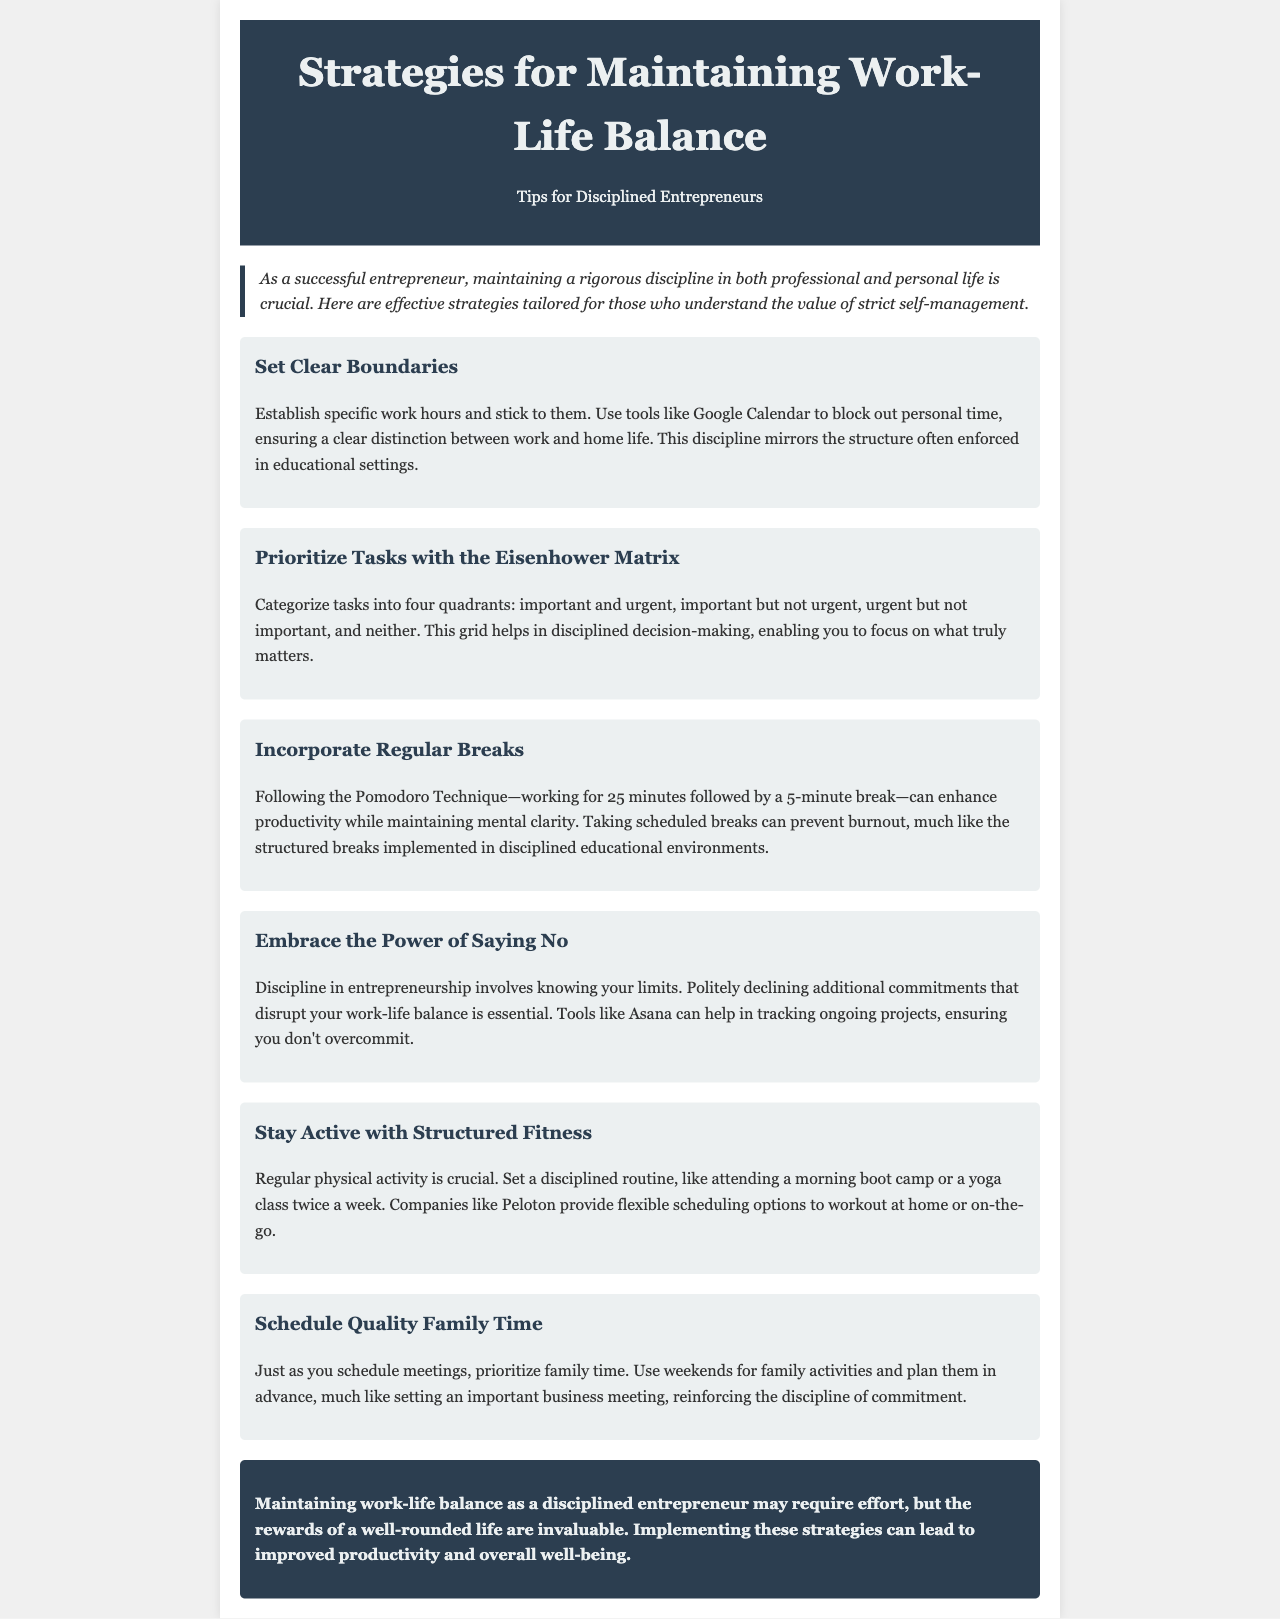What is the title of the newsletter? The title can be found in the header section of the document, prominently displayed.
Answer: Strategies for Maintaining Work-Life Balance What is the first strategy mentioned? The first strategy is presented in a dedicated section with a heading for clarity.
Answer: Set Clear Boundaries How many quadrants are in the Eisenhower Matrix? The Eisenhower Matrix is described as having four quadrants categorized by urgency and importance.
Answer: Four What technique is suggested for taking breaks? The break technique mentioned is named in relation to a structured approach to work periods.
Answer: Pomodoro Technique What type of physical activity is recommended? The document specifies activities that fall under a structured fitness routine for maintaining health.
Answer: Structured Fitness What is emphasized about committing to family time? The newsletter highlights the importance of scheduling specific times just like business meetings.
Answer: Scheduled What type of environment helps prevent burnout? A structured break routine is likened to practices found in educational environments that support mental health.
Answer: Structured breaks What is the document's primary audience? The language and content are aimed at a specific group of individuals in a particular profession.
Answer: Disciplined Entrepreneurs 